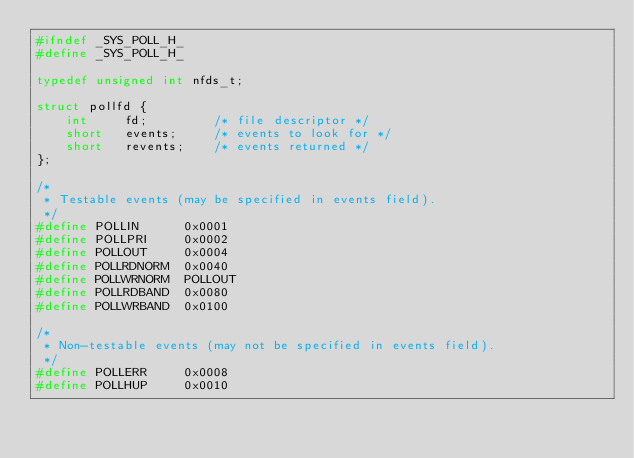Convert code to text. <code><loc_0><loc_0><loc_500><loc_500><_C_>#ifndef _SYS_POLL_H_
#define _SYS_POLL_H_

typedef unsigned int nfds_t;

struct pollfd {
	int		fd;			/* file descriptor */
	short	events;		/* events to look for */
	short	revents;	/* events returned */
};

/*
 * Testable events (may be specified in events field).
 */
#define	POLLIN		0x0001
#define	POLLPRI		0x0002
#define	POLLOUT		0x0004
#define	POLLRDNORM	0x0040
#define	POLLWRNORM	POLLOUT
#define	POLLRDBAND	0x0080
#define	POLLWRBAND	0x0100

/*
 * Non-testable events (may not be specified in events field).
 */
#define	POLLERR		0x0008
#define	POLLHUP		0x0010</code> 